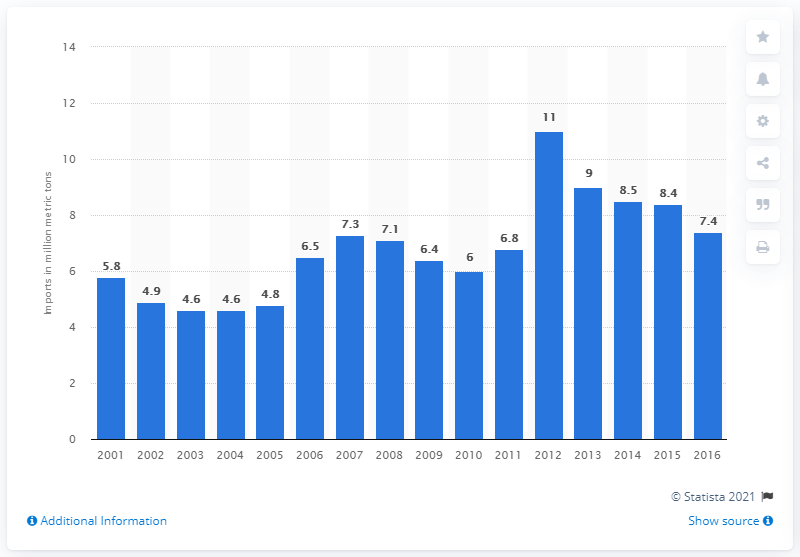Draw attention to some important aspects in this diagram. The total import of grain to the United States from 2001 to 2016 was 8.5 million metric tons. 